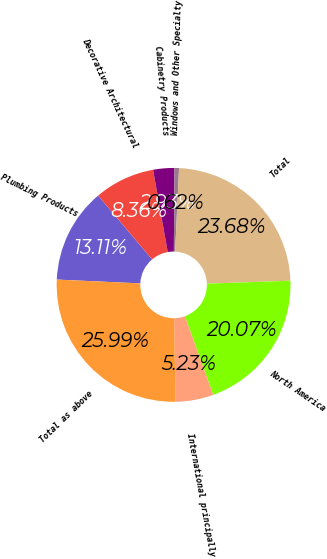Convert chart to OTSL. <chart><loc_0><loc_0><loc_500><loc_500><pie_chart><fcel>Plumbing Products<fcel>Decorative Architectural<fcel>Cabinetry Products<fcel>Windows and Other Specialty<fcel>Total<fcel>North America<fcel>International principally<fcel>Total as above<nl><fcel>13.11%<fcel>8.36%<fcel>2.93%<fcel>0.62%<fcel>23.68%<fcel>20.07%<fcel>5.23%<fcel>25.99%<nl></chart> 